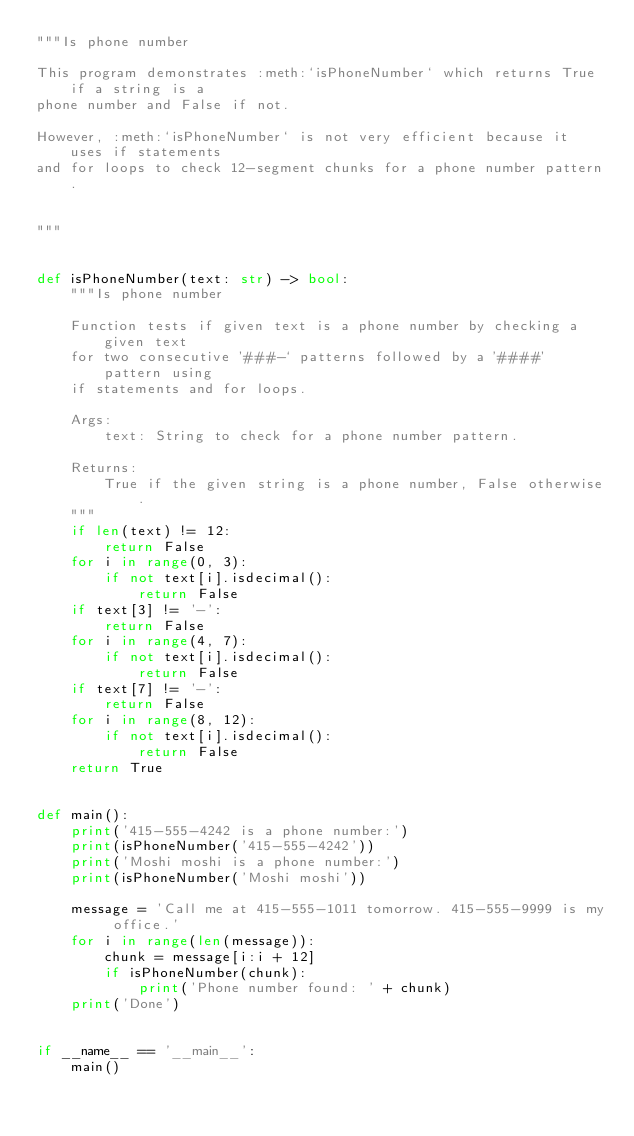<code> <loc_0><loc_0><loc_500><loc_500><_Python_>"""Is phone number

This program demonstrates :meth:`isPhoneNumber` which returns True if a string is a
phone number and False if not.

However, :meth:`isPhoneNumber` is not very efficient because it uses if statements
and for loops to check 12-segment chunks for a phone number pattern.


"""


def isPhoneNumber(text: str) -> bool:
    """Is phone number

    Function tests if given text is a phone number by checking a given text
    for two consecutive '###-` patterns followed by a '####' pattern using
    if statements and for loops.

    Args:
        text: String to check for a phone number pattern.

    Returns:
        True if the given string is a phone number, False otherwise.
    """
    if len(text) != 12:
        return False
    for i in range(0, 3):
        if not text[i].isdecimal():
            return False
    if text[3] != '-':
        return False
    for i in range(4, 7):
        if not text[i].isdecimal():
            return False
    if text[7] != '-':
        return False
    for i in range(8, 12):
        if not text[i].isdecimal():
            return False
    return True


def main():
    print('415-555-4242 is a phone number:')
    print(isPhoneNumber('415-555-4242'))
    print('Moshi moshi is a phone number:')
    print(isPhoneNumber('Moshi moshi'))

    message = 'Call me at 415-555-1011 tomorrow. 415-555-9999 is my office.'
    for i in range(len(message)):
        chunk = message[i:i + 12]
        if isPhoneNumber(chunk):
            print('Phone number found: ' + chunk)
    print('Done')


if __name__ == '__main__':
    main()
</code> 